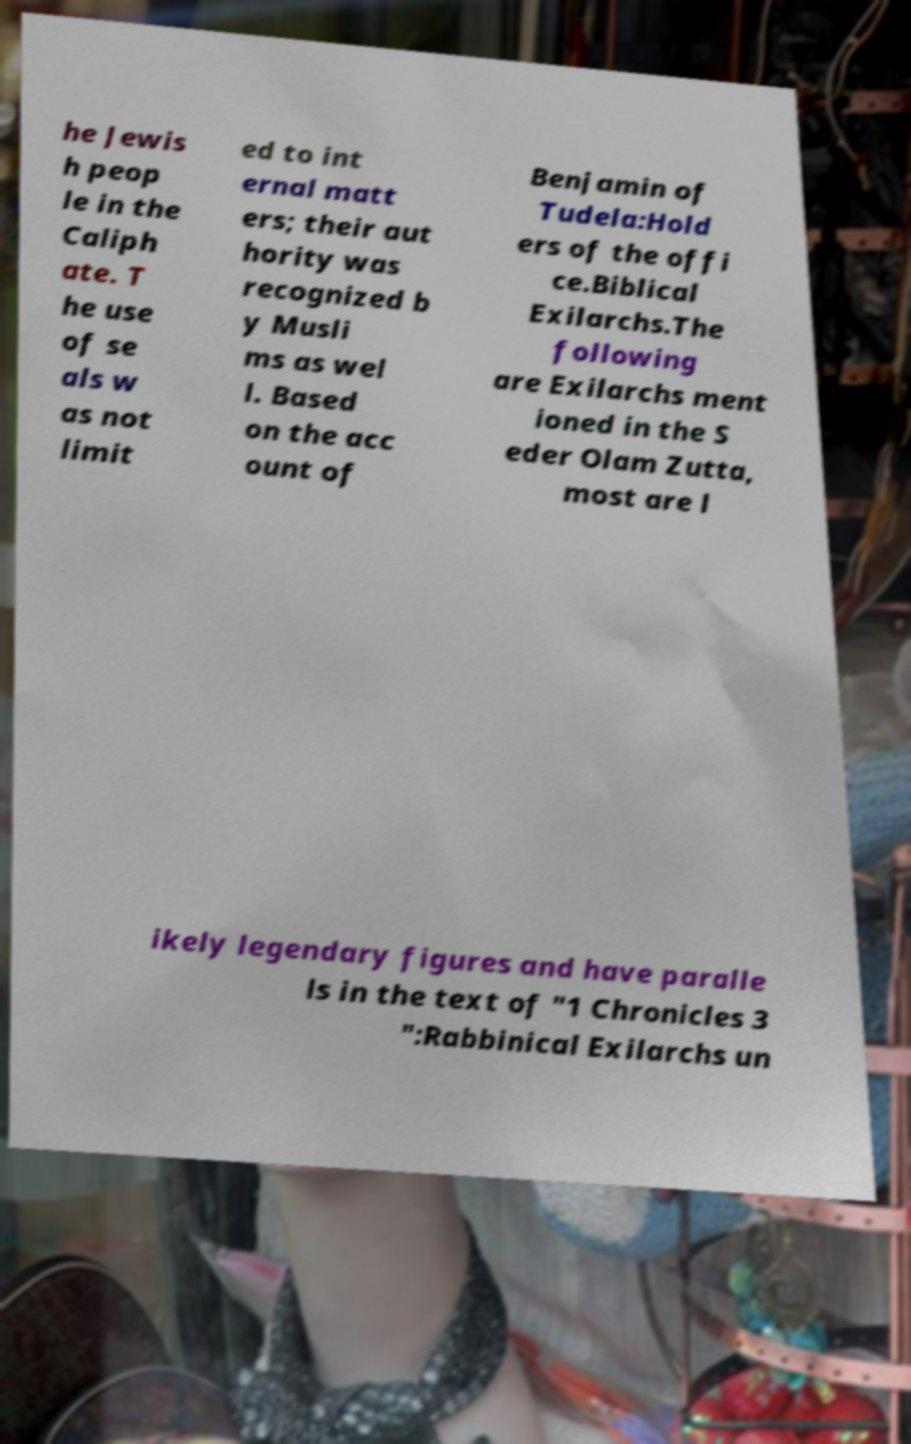Could you extract and type out the text from this image? he Jewis h peop le in the Caliph ate. T he use of se als w as not limit ed to int ernal matt ers; their aut hority was recognized b y Musli ms as wel l. Based on the acc ount of Benjamin of Tudela:Hold ers of the offi ce.Biblical Exilarchs.The following are Exilarchs ment ioned in the S eder Olam Zutta, most are l ikely legendary figures and have paralle ls in the text of "1 Chronicles 3 ":Rabbinical Exilarchs un 